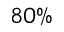Convert formula to latex. <formula><loc_0><loc_0><loc_500><loc_500>8 0 \%</formula> 